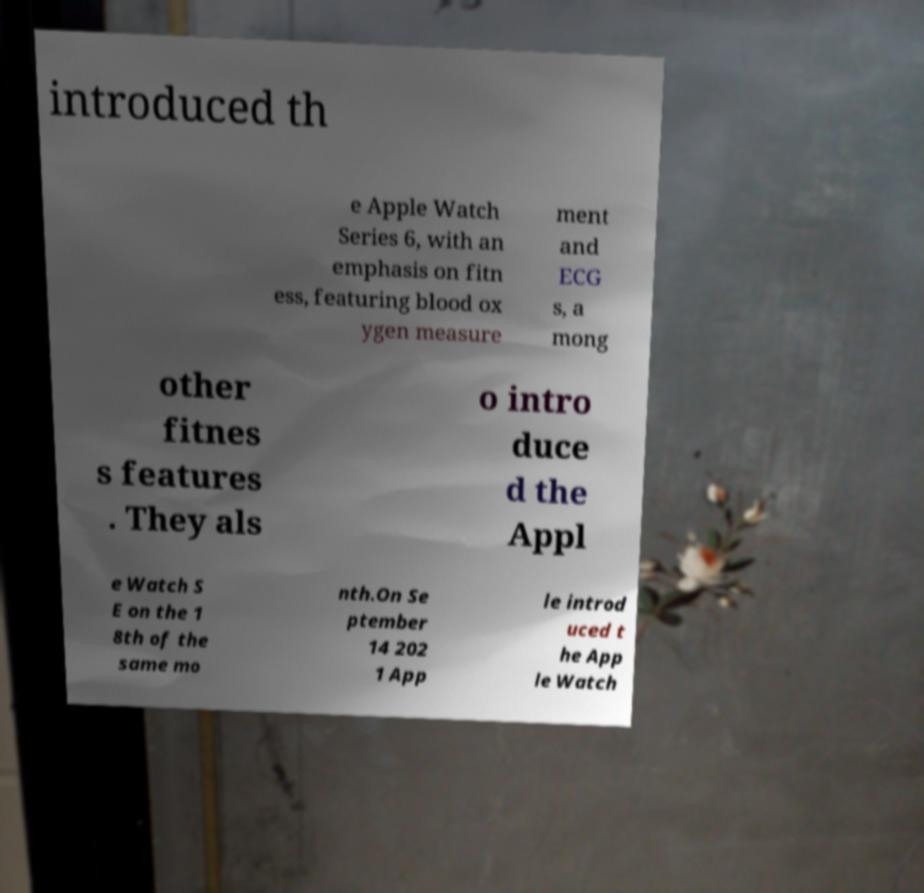For documentation purposes, I need the text within this image transcribed. Could you provide that? introduced th e Apple Watch Series 6, with an emphasis on fitn ess, featuring blood ox ygen measure ment and ECG s, a mong other fitnes s features . They als o intro duce d the Appl e Watch S E on the 1 8th of the same mo nth.On Se ptember 14 202 1 App le introd uced t he App le Watch 